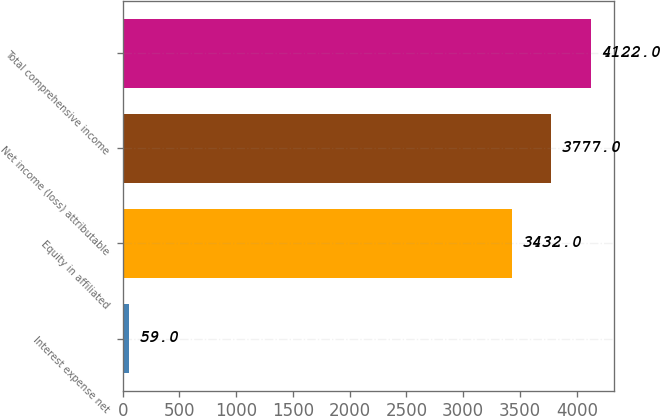Convert chart to OTSL. <chart><loc_0><loc_0><loc_500><loc_500><bar_chart><fcel>Interest expense net<fcel>Equity in affiliated<fcel>Net income (loss) attributable<fcel>Total comprehensive income<nl><fcel>59<fcel>3432<fcel>3777<fcel>4122<nl></chart> 